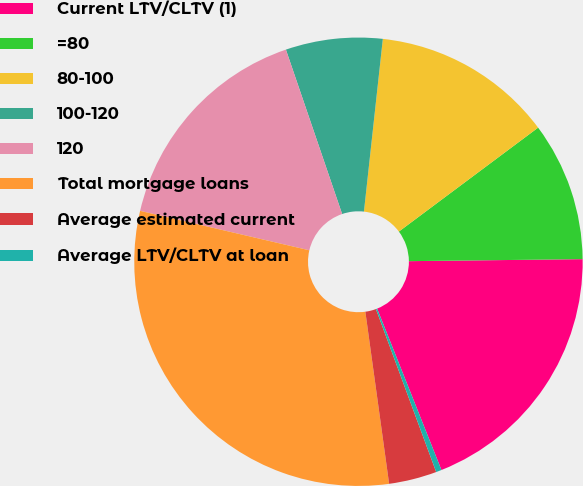<chart> <loc_0><loc_0><loc_500><loc_500><pie_chart><fcel>Current LTV/CLTV (1)<fcel>=80<fcel>80-100<fcel>100-120<fcel>120<fcel>Total mortgage loans<fcel>Average estimated current<fcel>Average LTV/CLTV at loan<nl><fcel>19.15%<fcel>10.02%<fcel>13.06%<fcel>6.98%<fcel>16.11%<fcel>30.83%<fcel>3.45%<fcel>0.4%<nl></chart> 